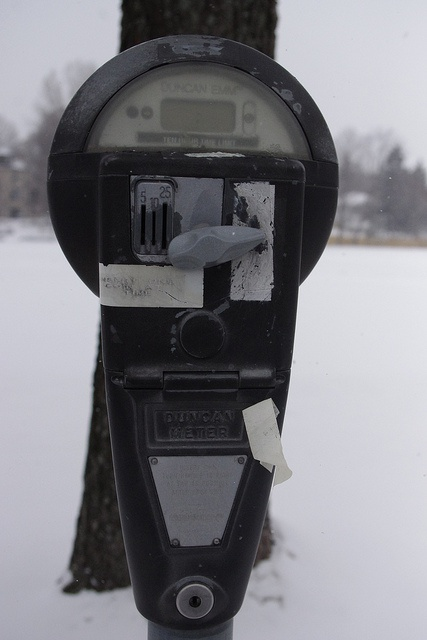Describe the objects in this image and their specific colors. I can see a parking meter in lightgray, black, gray, and darkgray tones in this image. 